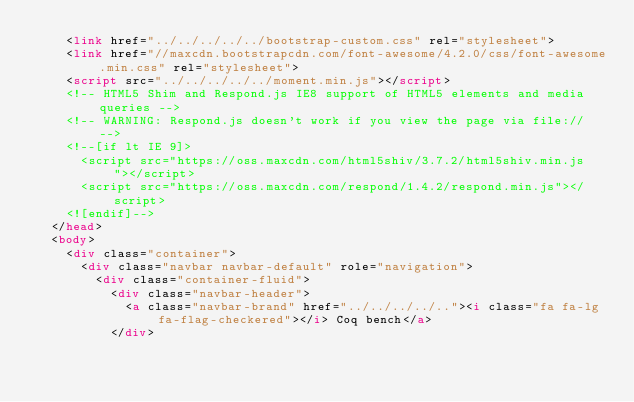Convert code to text. <code><loc_0><loc_0><loc_500><loc_500><_HTML_>    <link href="../../../../../bootstrap-custom.css" rel="stylesheet">
    <link href="//maxcdn.bootstrapcdn.com/font-awesome/4.2.0/css/font-awesome.min.css" rel="stylesheet">
    <script src="../../../../../moment.min.js"></script>
    <!-- HTML5 Shim and Respond.js IE8 support of HTML5 elements and media queries -->
    <!-- WARNING: Respond.js doesn't work if you view the page via file:// -->
    <!--[if lt IE 9]>
      <script src="https://oss.maxcdn.com/html5shiv/3.7.2/html5shiv.min.js"></script>
      <script src="https://oss.maxcdn.com/respond/1.4.2/respond.min.js"></script>
    <![endif]-->
  </head>
  <body>
    <div class="container">
      <div class="navbar navbar-default" role="navigation">
        <div class="container-fluid">
          <div class="navbar-header">
            <a class="navbar-brand" href="../../../../.."><i class="fa fa-lg fa-flag-checkered"></i> Coq bench</a>
          </div></code> 